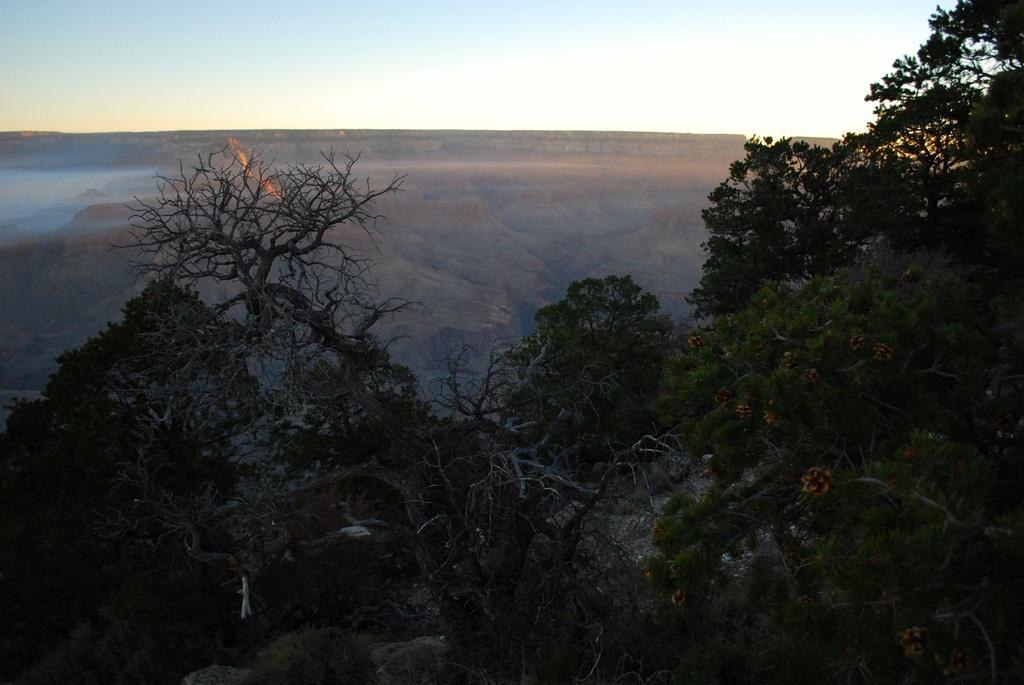How would you summarize this image in a sentence or two? In this image, there are some trees. There is a hill in the middle of the image. There is a sky at the top of the image. 